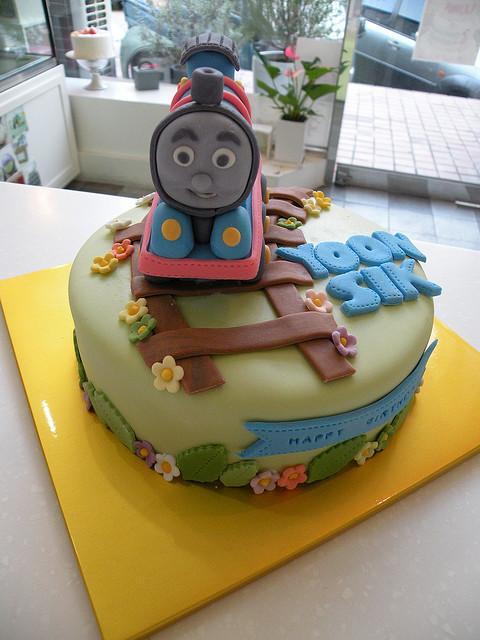What type of frosting was used for this cake?
Write a very short answer. Fondant. What is this object?
Give a very brief answer. Cake. What game are the characters on the cake from?
Write a very short answer. Thomas train. Where is the cake?
Concise answer only. Table. 